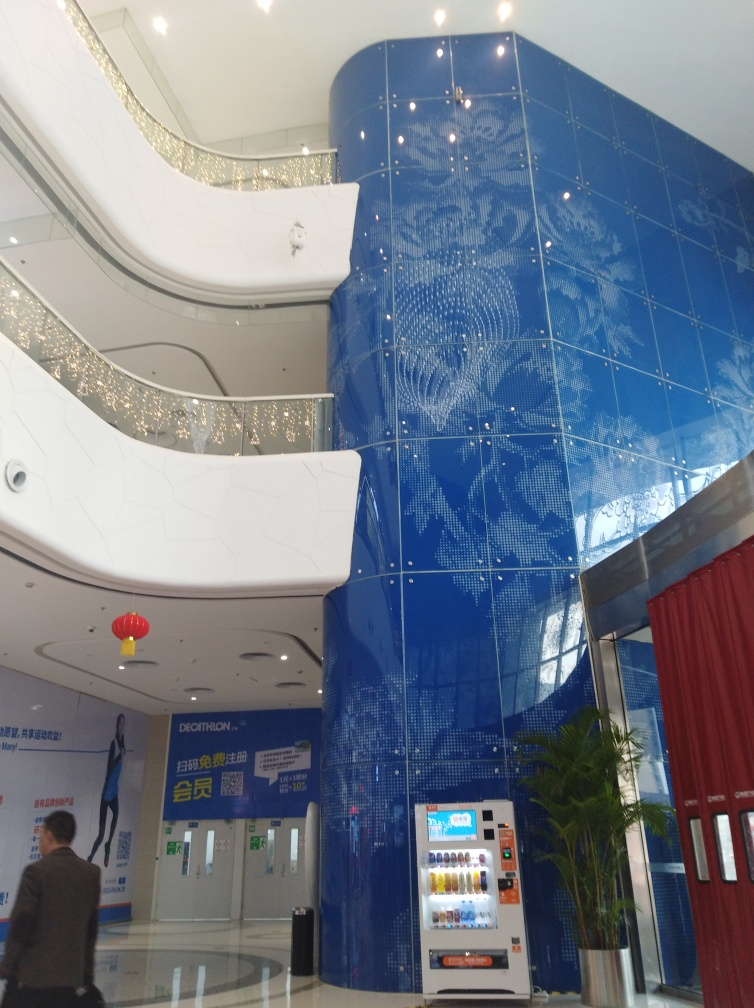How might this space be used, based on the design elements we see? Judging by the grandeur of the architectural style and the design elements, this space could serve multiple purposes. The open layout and the prominent art installation suggest it might be a lobby or a common area in a cultural or commercial building, perhaps a mall, hotel, or corporate headquarters. It's designed to impress and to navigate large groups of people efficiently while providing a visually stimulating environment. 